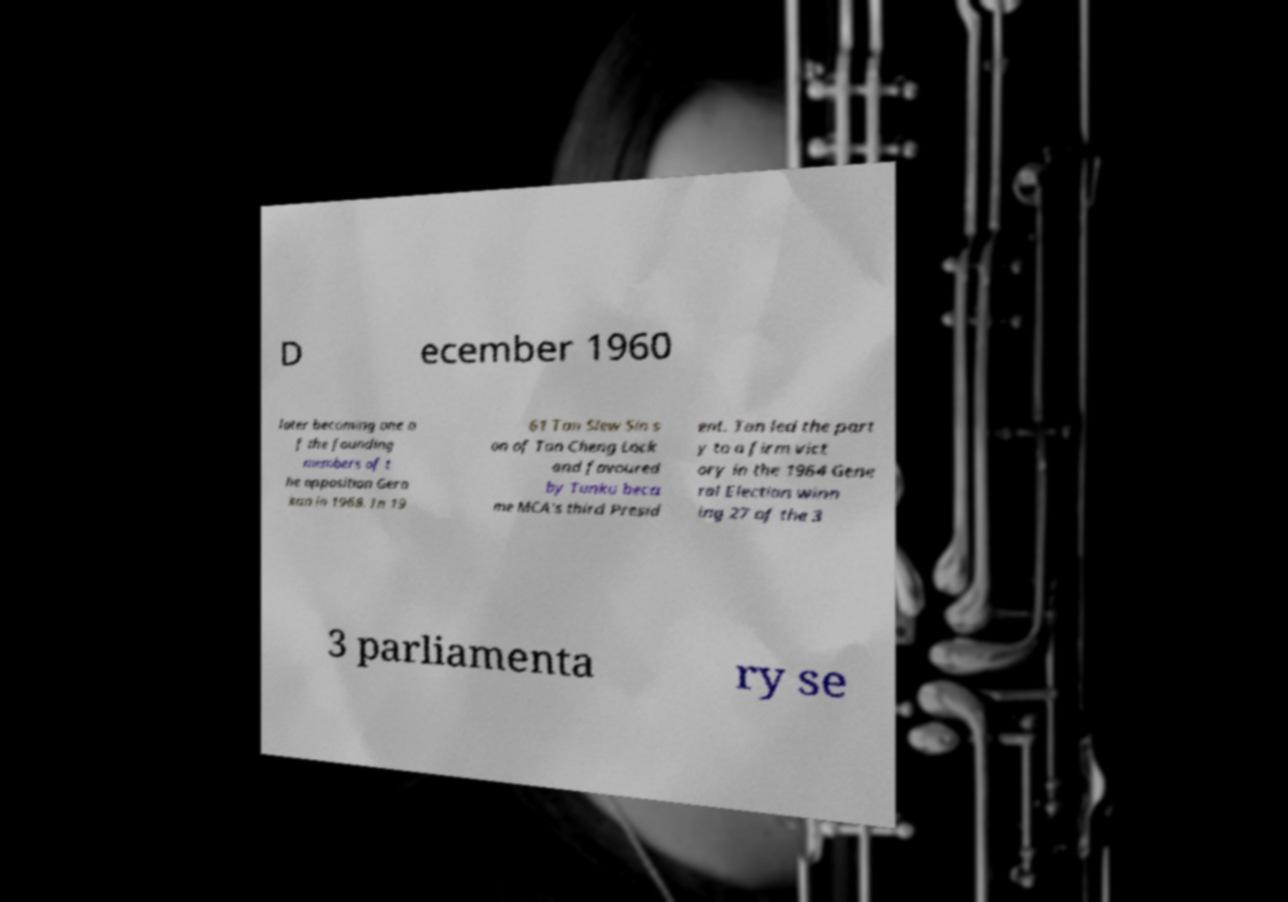For documentation purposes, I need the text within this image transcribed. Could you provide that? D ecember 1960 later becoming one o f the founding members of t he opposition Gera kan in 1968. In 19 61 Tan Siew Sin s on of Tan Cheng Lock and favoured by Tunku beca me MCA's third Presid ent. Tan led the part y to a firm vict ory in the 1964 Gene ral Election winn ing 27 of the 3 3 parliamenta ry se 